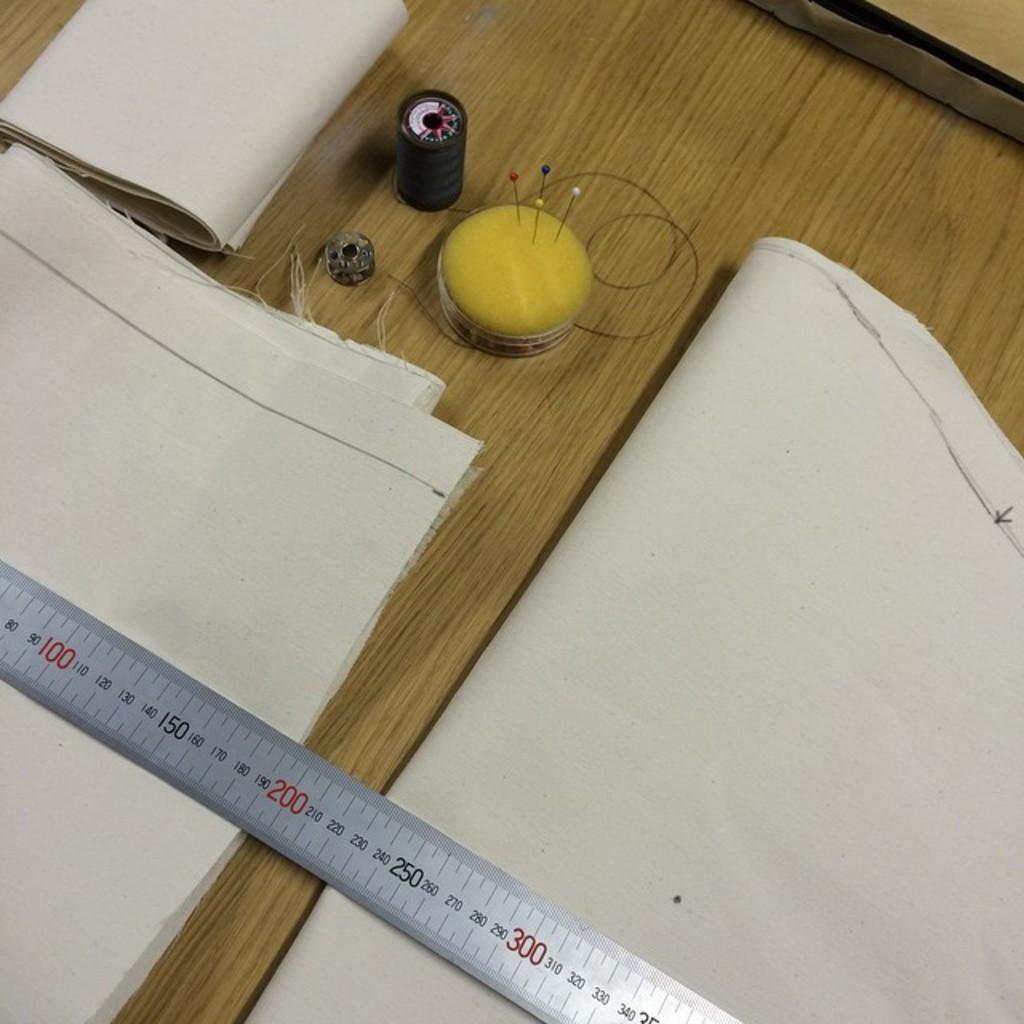<image>
Write a terse but informative summary of the picture. 200 centi meters of fabric are being measured. 